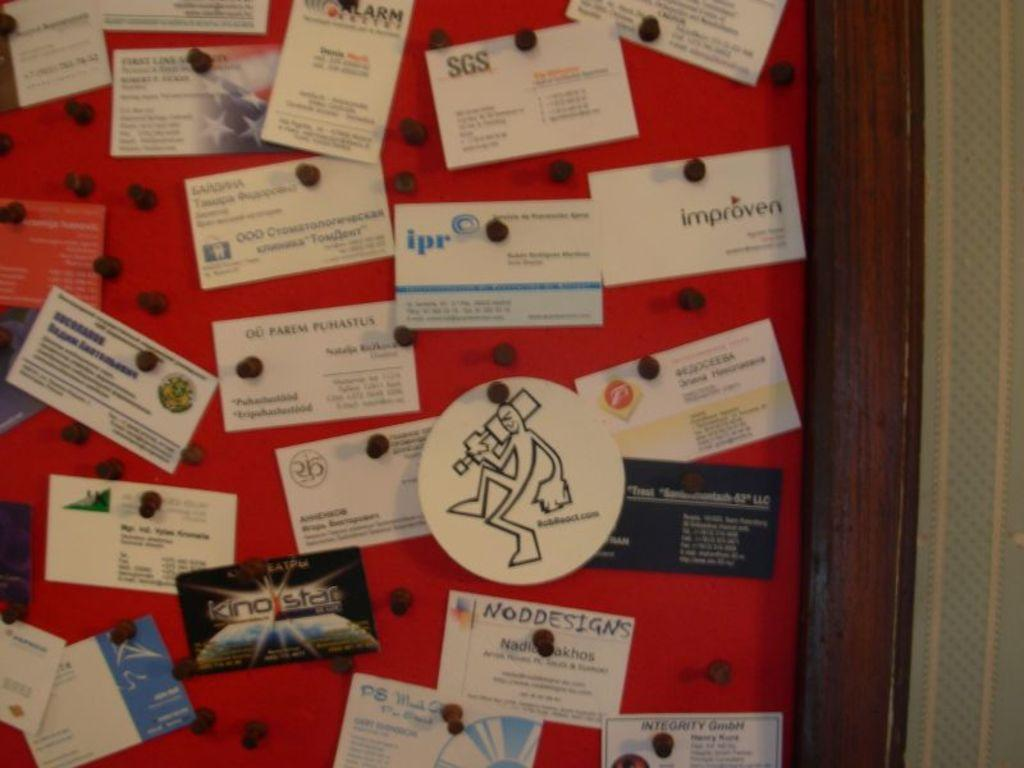What objects are present in the image? There are cards in the image. How are the cards arranged or positioned? The cards are placed on a board. What type of vein can be seen running through the cards in the image? There are no veins present in the image; it features cards placed on a board. What tools might a carpenter use to create the board in the image? The image does not show the process of creating the board or any tools used, so it cannot be determined from the image. 